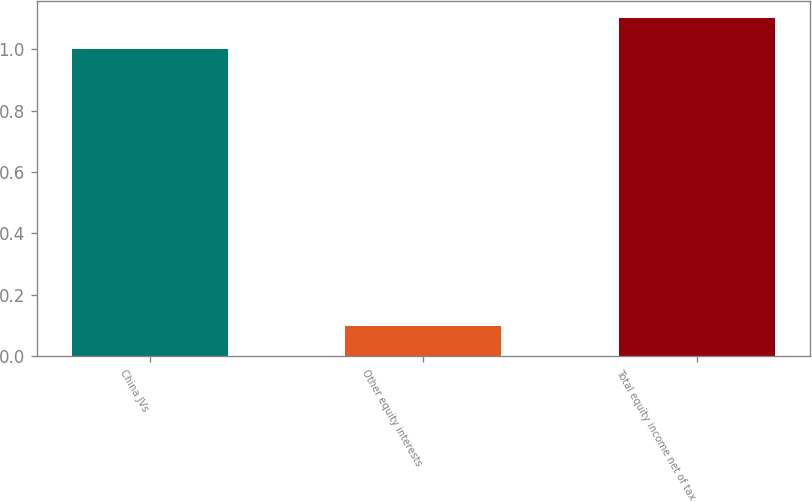Convert chart to OTSL. <chart><loc_0><loc_0><loc_500><loc_500><bar_chart><fcel>China JVs<fcel>Other equity interests<fcel>Total equity income net of tax<nl><fcel>1<fcel>0.1<fcel>1.1<nl></chart> 